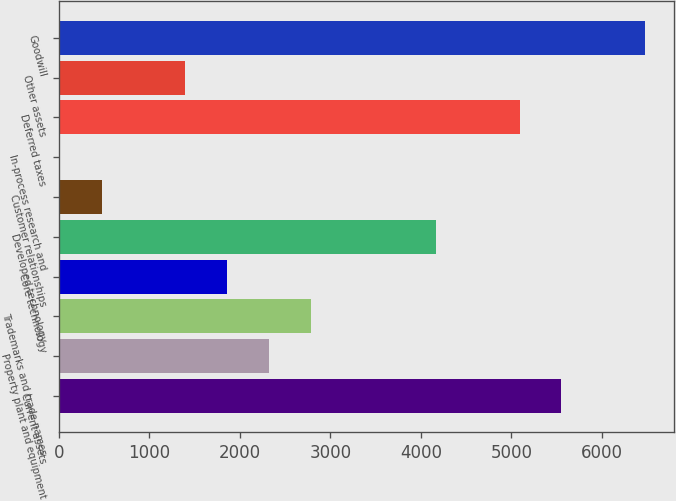Convert chart to OTSL. <chart><loc_0><loc_0><loc_500><loc_500><bar_chart><fcel>Current assets<fcel>Property plant and equipment<fcel>Trademarks and trade names<fcel>Core technology<fcel>Developed technology<fcel>Customer relationships<fcel>In-process research and<fcel>Deferred taxes<fcel>Other assets<fcel>Goodwill<nl><fcel>5551.6<fcel>2319.7<fcel>2781.4<fcel>1858<fcel>4166.5<fcel>472.9<fcel>11.2<fcel>5089.9<fcel>1396.3<fcel>6475<nl></chart> 